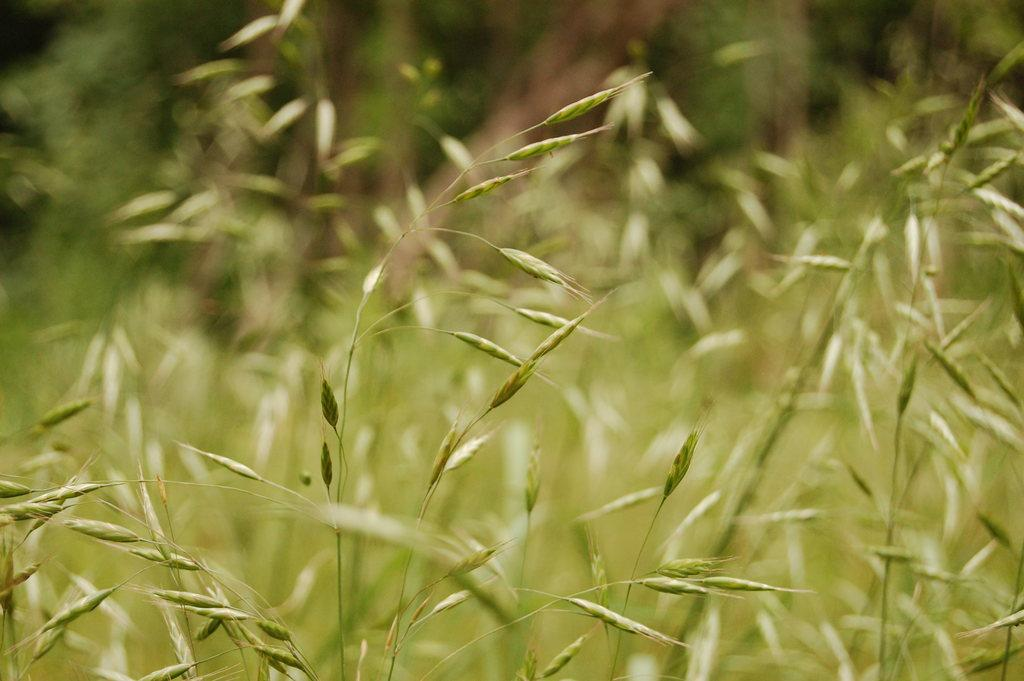What type of living organisms can be seen in the image? Plants can be seen in the image. Can you describe the background of the image? The background of the image is blurred. What type of flag can be seen waving in the wind in the image? There is no flag or wind present in the image; it features plants and a blurred background. How many bags of popcorn are visible in the image? There are no bags of popcorn present in the image. 